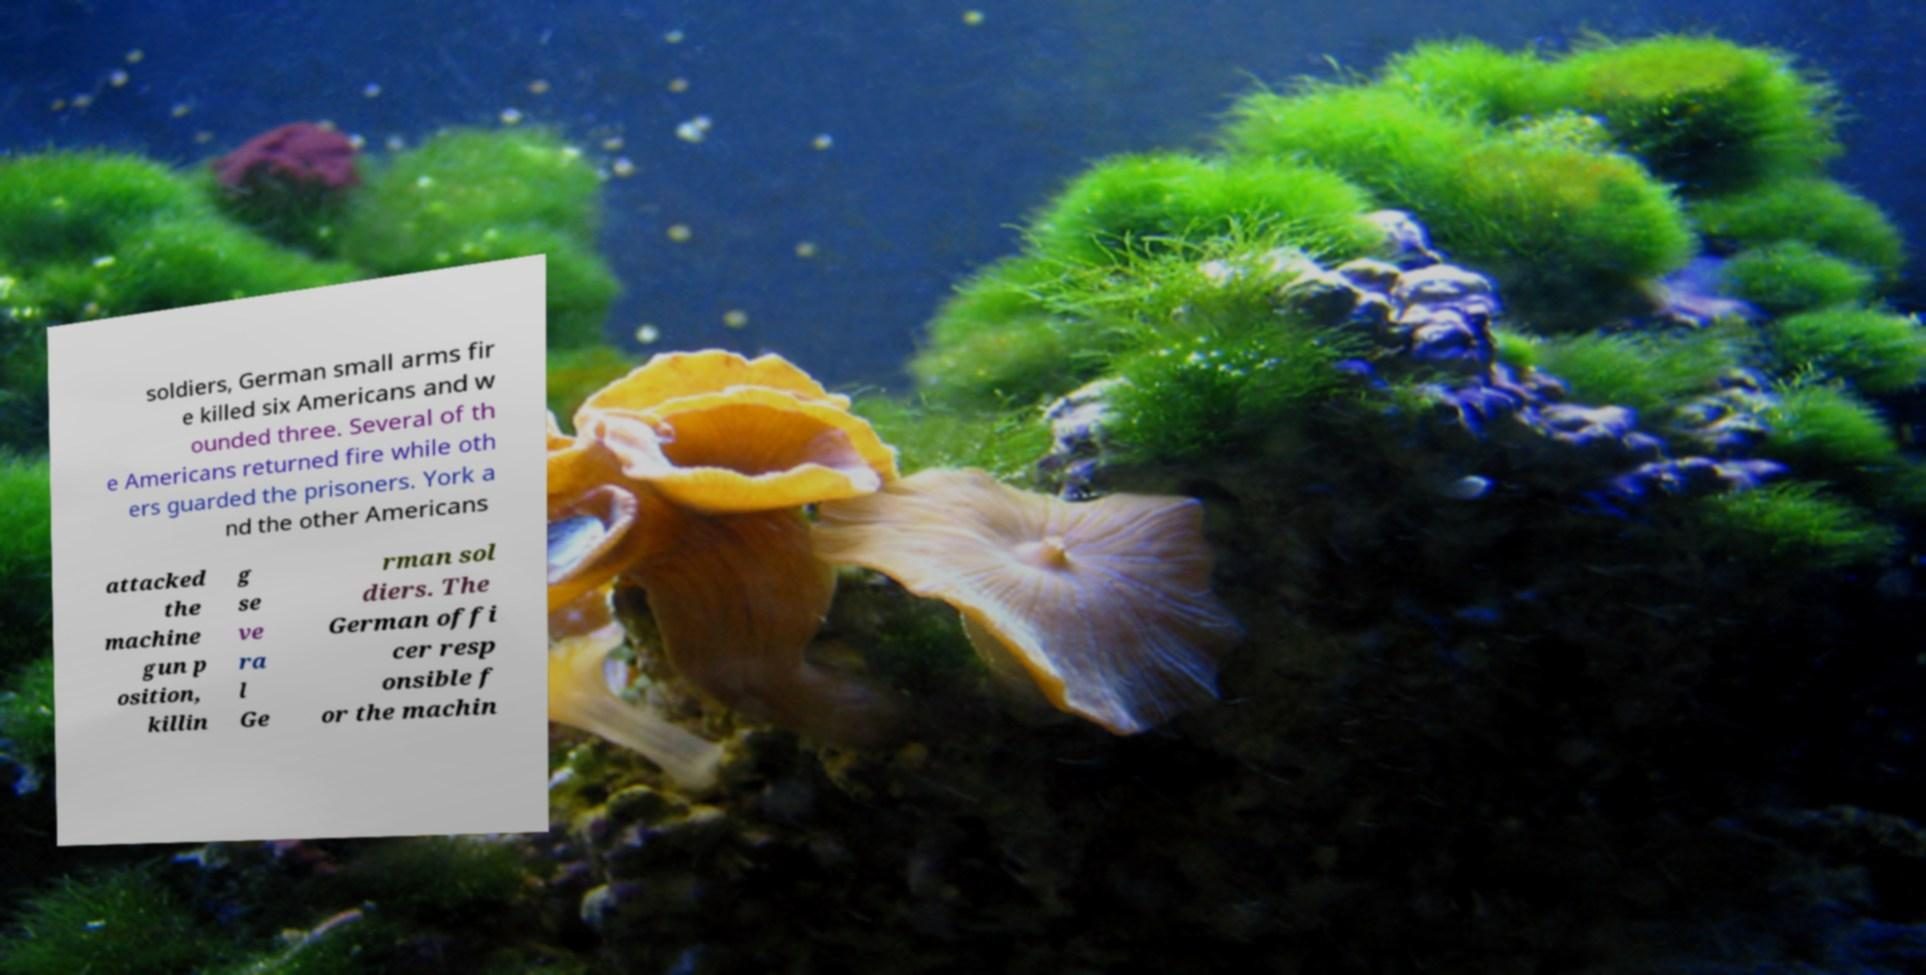Can you read and provide the text displayed in the image?This photo seems to have some interesting text. Can you extract and type it out for me? soldiers, German small arms fir e killed six Americans and w ounded three. Several of th e Americans returned fire while oth ers guarded the prisoners. York a nd the other Americans attacked the machine gun p osition, killin g se ve ra l Ge rman sol diers. The German offi cer resp onsible f or the machin 